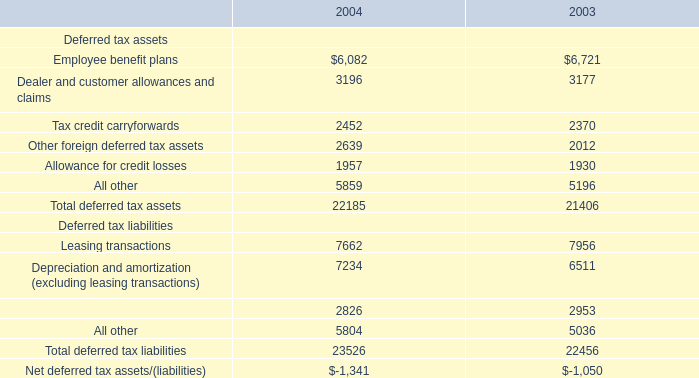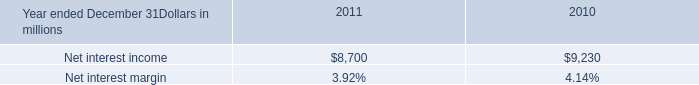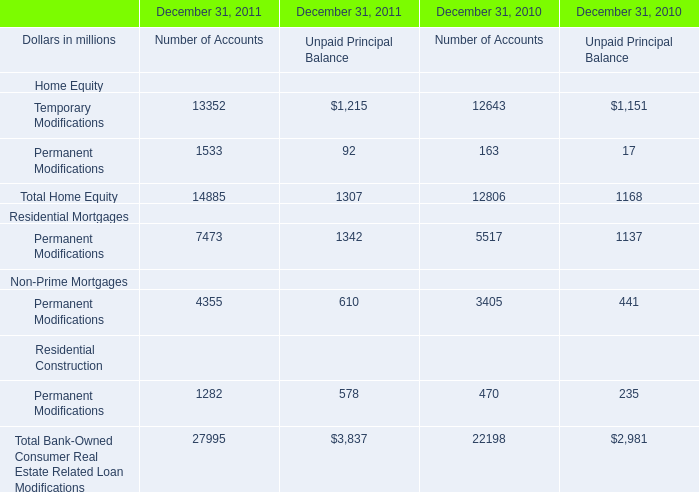how much more was the residential mortgage foreclosures in 2011 than in 2010? 
Computations: (324 - 71)
Answer: 253.0. 